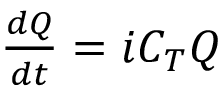<formula> <loc_0><loc_0><loc_500><loc_500>\begin{array} { r } { \frac { d Q } { d t } = i C _ { T } Q } \end{array}</formula> 